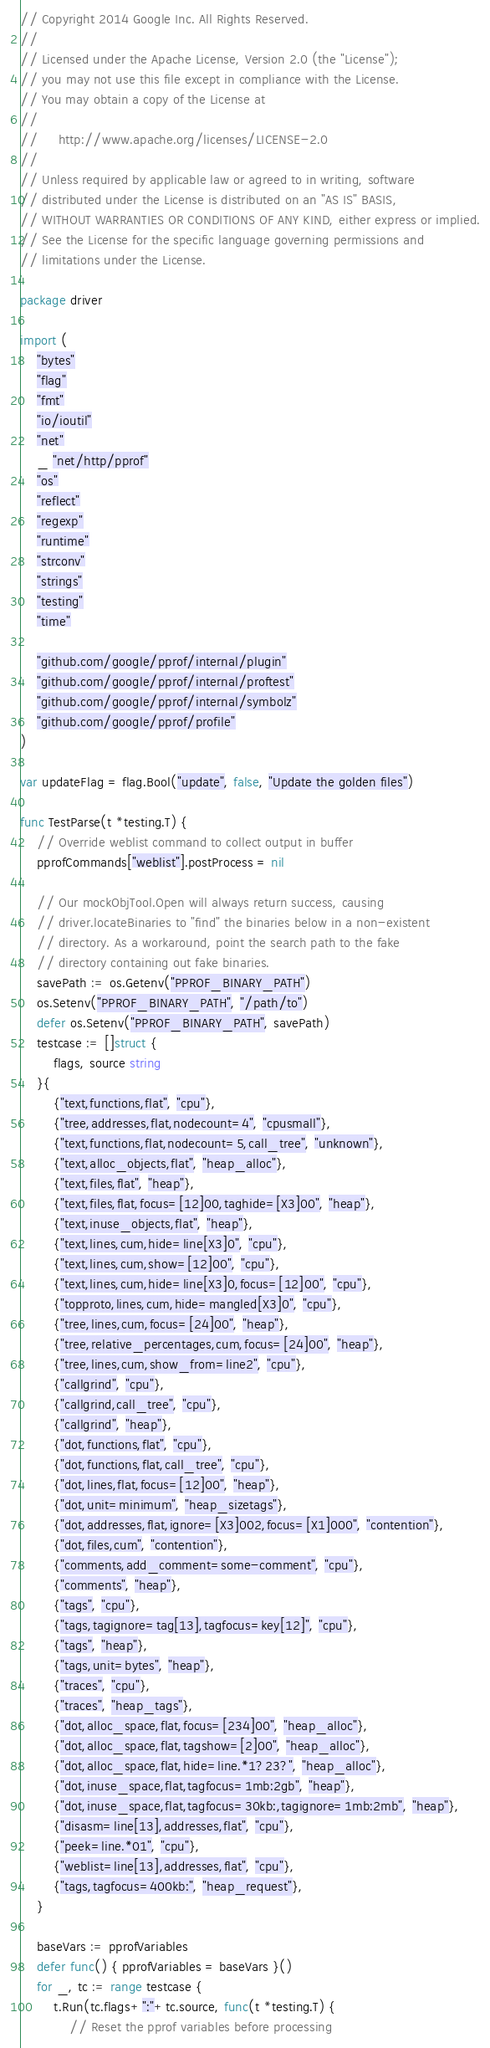<code> <loc_0><loc_0><loc_500><loc_500><_Go_>// Copyright 2014 Google Inc. All Rights Reserved.
//
// Licensed under the Apache License, Version 2.0 (the "License");
// you may not use this file except in compliance with the License.
// You may obtain a copy of the License at
//
//     http://www.apache.org/licenses/LICENSE-2.0
//
// Unless required by applicable law or agreed to in writing, software
// distributed under the License is distributed on an "AS IS" BASIS,
// WITHOUT WARRANTIES OR CONDITIONS OF ANY KIND, either express or implied.
// See the License for the specific language governing permissions and
// limitations under the License.

package driver

import (
	"bytes"
	"flag"
	"fmt"
	"io/ioutil"
	"net"
	_ "net/http/pprof"
	"os"
	"reflect"
	"regexp"
	"runtime"
	"strconv"
	"strings"
	"testing"
	"time"

	"github.com/google/pprof/internal/plugin"
	"github.com/google/pprof/internal/proftest"
	"github.com/google/pprof/internal/symbolz"
	"github.com/google/pprof/profile"
)

var updateFlag = flag.Bool("update", false, "Update the golden files")

func TestParse(t *testing.T) {
	// Override weblist command to collect output in buffer
	pprofCommands["weblist"].postProcess = nil

	// Our mockObjTool.Open will always return success, causing
	// driver.locateBinaries to "find" the binaries below in a non-existent
	// directory. As a workaround, point the search path to the fake
	// directory containing out fake binaries.
	savePath := os.Getenv("PPROF_BINARY_PATH")
	os.Setenv("PPROF_BINARY_PATH", "/path/to")
	defer os.Setenv("PPROF_BINARY_PATH", savePath)
	testcase := []struct {
		flags, source string
	}{
		{"text,functions,flat", "cpu"},
		{"tree,addresses,flat,nodecount=4", "cpusmall"},
		{"text,functions,flat,nodecount=5,call_tree", "unknown"},
		{"text,alloc_objects,flat", "heap_alloc"},
		{"text,files,flat", "heap"},
		{"text,files,flat,focus=[12]00,taghide=[X3]00", "heap"},
		{"text,inuse_objects,flat", "heap"},
		{"text,lines,cum,hide=line[X3]0", "cpu"},
		{"text,lines,cum,show=[12]00", "cpu"},
		{"text,lines,cum,hide=line[X3]0,focus=[12]00", "cpu"},
		{"topproto,lines,cum,hide=mangled[X3]0", "cpu"},
		{"tree,lines,cum,focus=[24]00", "heap"},
		{"tree,relative_percentages,cum,focus=[24]00", "heap"},
		{"tree,lines,cum,show_from=line2", "cpu"},
		{"callgrind", "cpu"},
		{"callgrind,call_tree", "cpu"},
		{"callgrind", "heap"},
		{"dot,functions,flat", "cpu"},
		{"dot,functions,flat,call_tree", "cpu"},
		{"dot,lines,flat,focus=[12]00", "heap"},
		{"dot,unit=minimum", "heap_sizetags"},
		{"dot,addresses,flat,ignore=[X3]002,focus=[X1]000", "contention"},
		{"dot,files,cum", "contention"},
		{"comments,add_comment=some-comment", "cpu"},
		{"comments", "heap"},
		{"tags", "cpu"},
		{"tags,tagignore=tag[13],tagfocus=key[12]", "cpu"},
		{"tags", "heap"},
		{"tags,unit=bytes", "heap"},
		{"traces", "cpu"},
		{"traces", "heap_tags"},
		{"dot,alloc_space,flat,focus=[234]00", "heap_alloc"},
		{"dot,alloc_space,flat,tagshow=[2]00", "heap_alloc"},
		{"dot,alloc_space,flat,hide=line.*1?23?", "heap_alloc"},
		{"dot,inuse_space,flat,tagfocus=1mb:2gb", "heap"},
		{"dot,inuse_space,flat,tagfocus=30kb:,tagignore=1mb:2mb", "heap"},
		{"disasm=line[13],addresses,flat", "cpu"},
		{"peek=line.*01", "cpu"},
		{"weblist=line[13],addresses,flat", "cpu"},
		{"tags,tagfocus=400kb:", "heap_request"},
	}

	baseVars := pprofVariables
	defer func() { pprofVariables = baseVars }()
	for _, tc := range testcase {
		t.Run(tc.flags+":"+tc.source, func(t *testing.T) {
			// Reset the pprof variables before processing</code> 